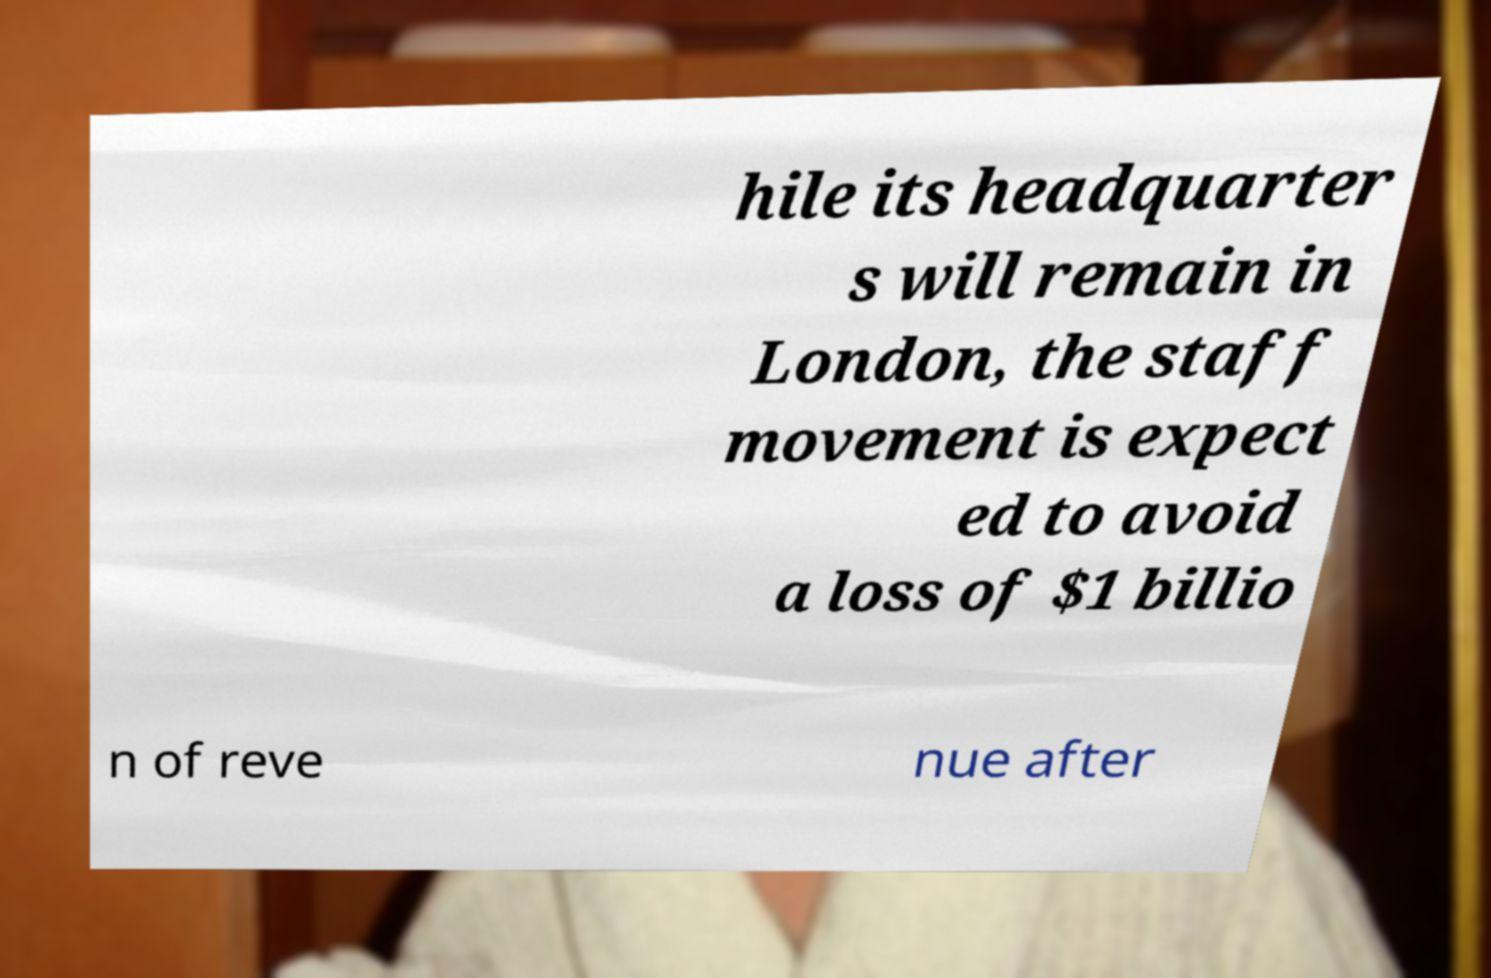Please read and relay the text visible in this image. What does it say? hile its headquarter s will remain in London, the staff movement is expect ed to avoid a loss of $1 billio n of reve nue after 